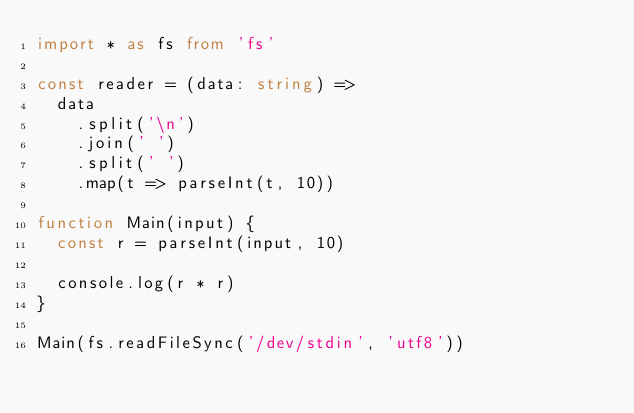<code> <loc_0><loc_0><loc_500><loc_500><_TypeScript_>import * as fs from 'fs'

const reader = (data: string) =>
  data
    .split('\n')
    .join(' ')
    .split(' ')
    .map(t => parseInt(t, 10))

function Main(input) {
  const r = parseInt(input, 10)

  console.log(r * r)
}

Main(fs.readFileSync('/dev/stdin', 'utf8'))
</code> 